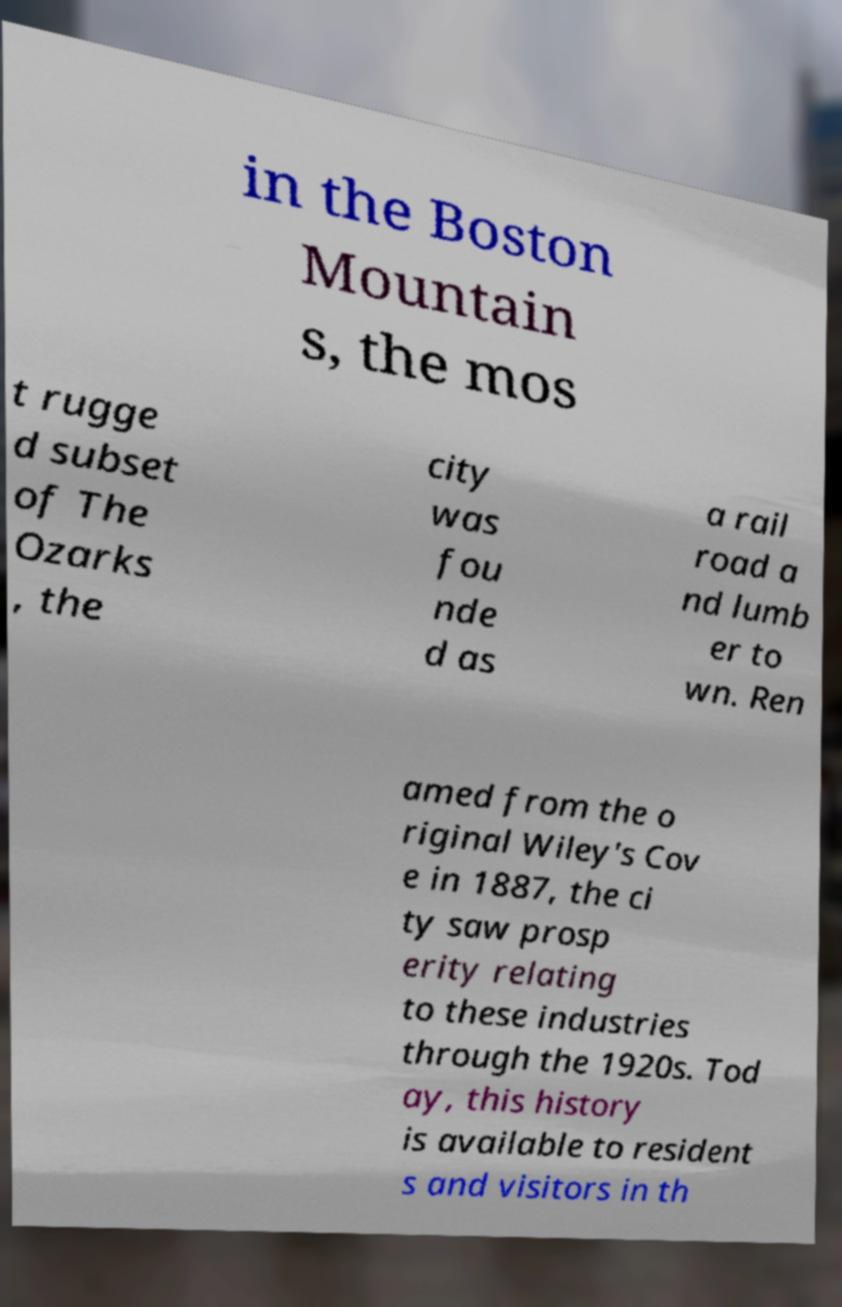Please read and relay the text visible in this image. What does it say? in the Boston Mountain s, the mos t rugge d subset of The Ozarks , the city was fou nde d as a rail road a nd lumb er to wn. Ren amed from the o riginal Wiley's Cov e in 1887, the ci ty saw prosp erity relating to these industries through the 1920s. Tod ay, this history is available to resident s and visitors in th 